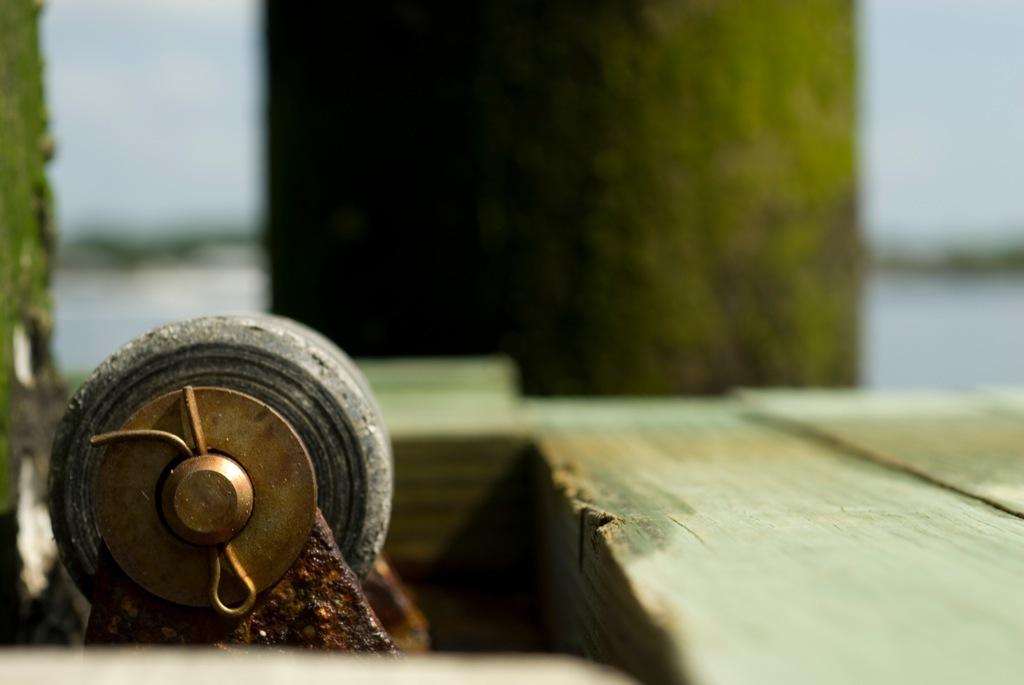What is the shape of the object at the bottom of the image? The object at the bottom of the image is wheel-shaped. What type of material is used for the base in the image? The base in the image is made of wood. How would you describe the background of the image? The background of the image is blurry. How many lizards can be seen climbing the wooden base in the image? There are no lizards present in the image; it only features a wheel-shaped object and a wooden base. What is the size of the wheel-shaped object in the image? The size of the wheel-shaped object cannot be determined from the image alone, as there is no reference for scale. 